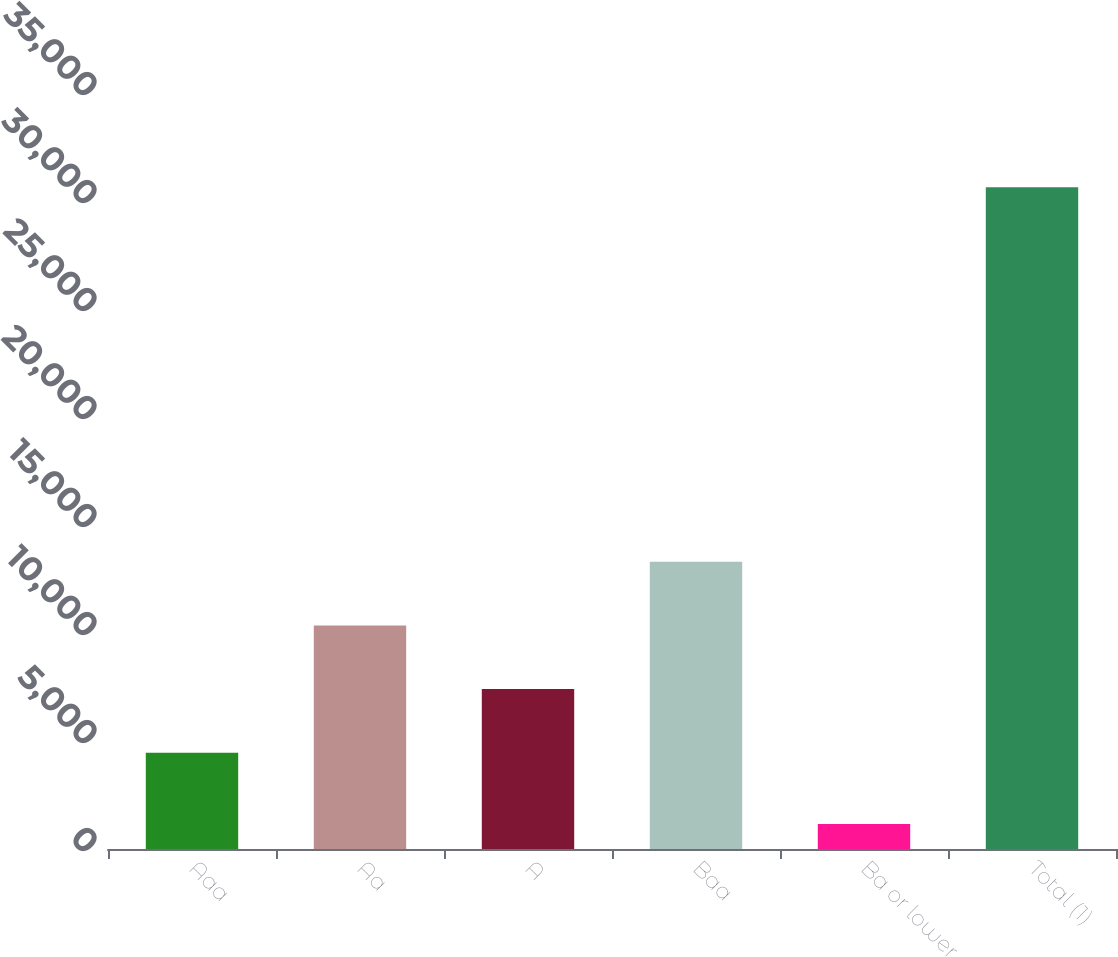Convert chart. <chart><loc_0><loc_0><loc_500><loc_500><bar_chart><fcel>Aaa<fcel>Aa<fcel>A<fcel>Baa<fcel>Ba or lower<fcel>Total (1)<nl><fcel>4455<fcel>10352<fcel>7403.5<fcel>13300.5<fcel>1155<fcel>30640<nl></chart> 